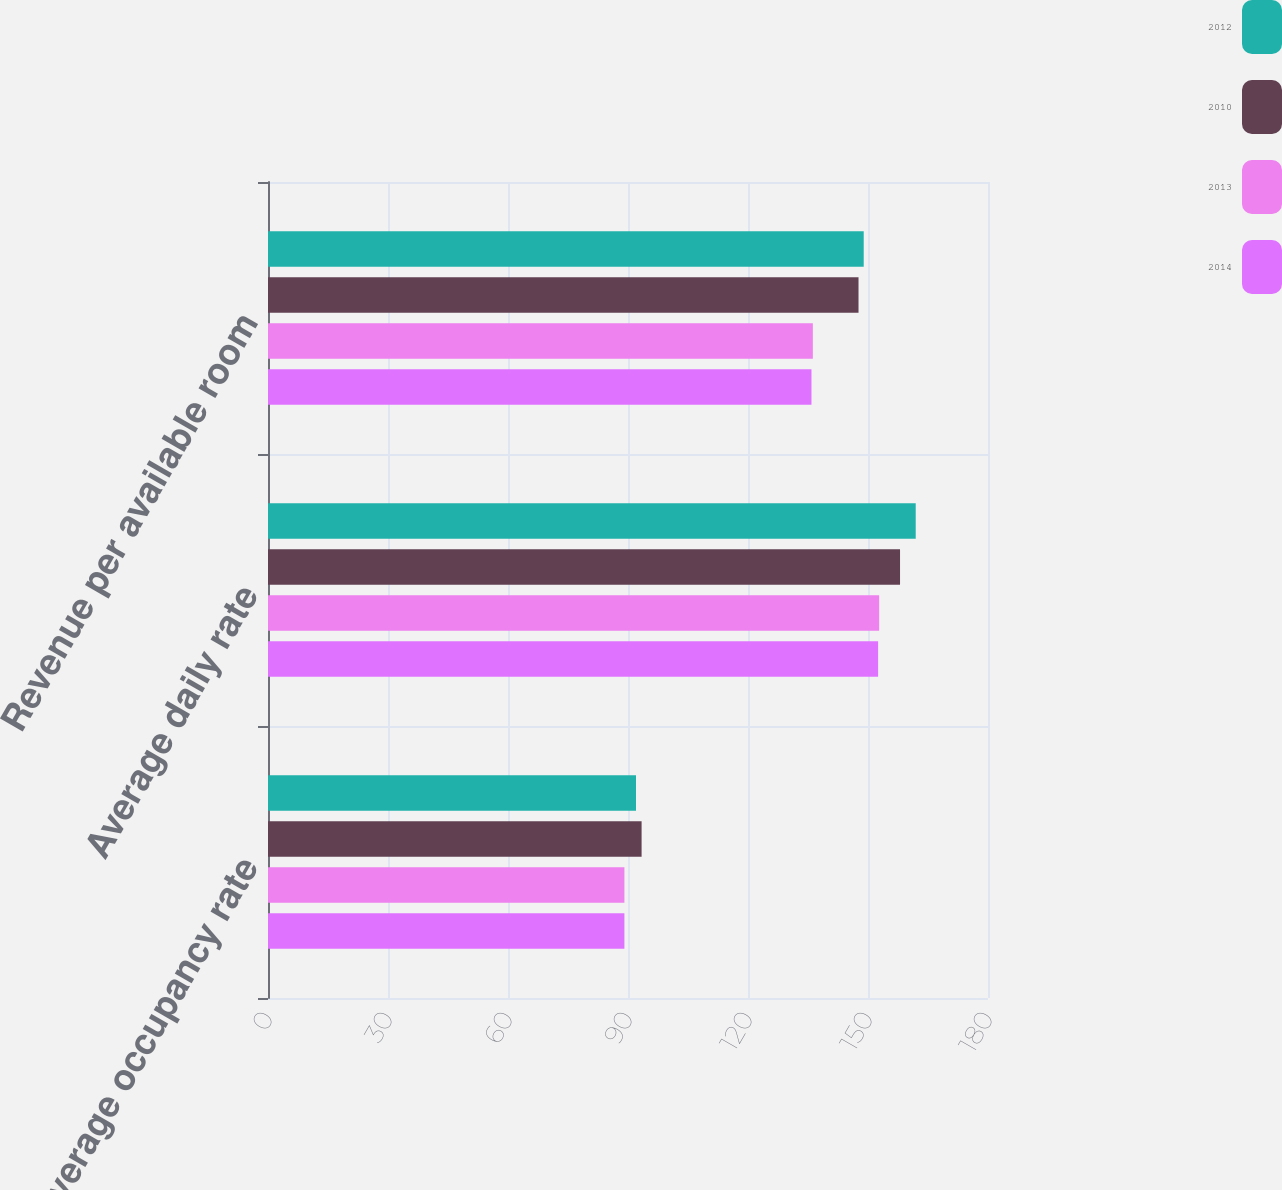Convert chart to OTSL. <chart><loc_0><loc_0><loc_500><loc_500><stacked_bar_chart><ecel><fcel>Average occupancy rate<fcel>Average daily rate<fcel>Revenue per available room<nl><fcel>2012<fcel>92<fcel>161.93<fcel>148.93<nl><fcel>2010<fcel>93.4<fcel>158.01<fcel>147.63<nl><fcel>2013<fcel>89.1<fcel>152.79<fcel>136.21<nl><fcel>2014<fcel>89.1<fcel>152.53<fcel>135.87<nl></chart> 